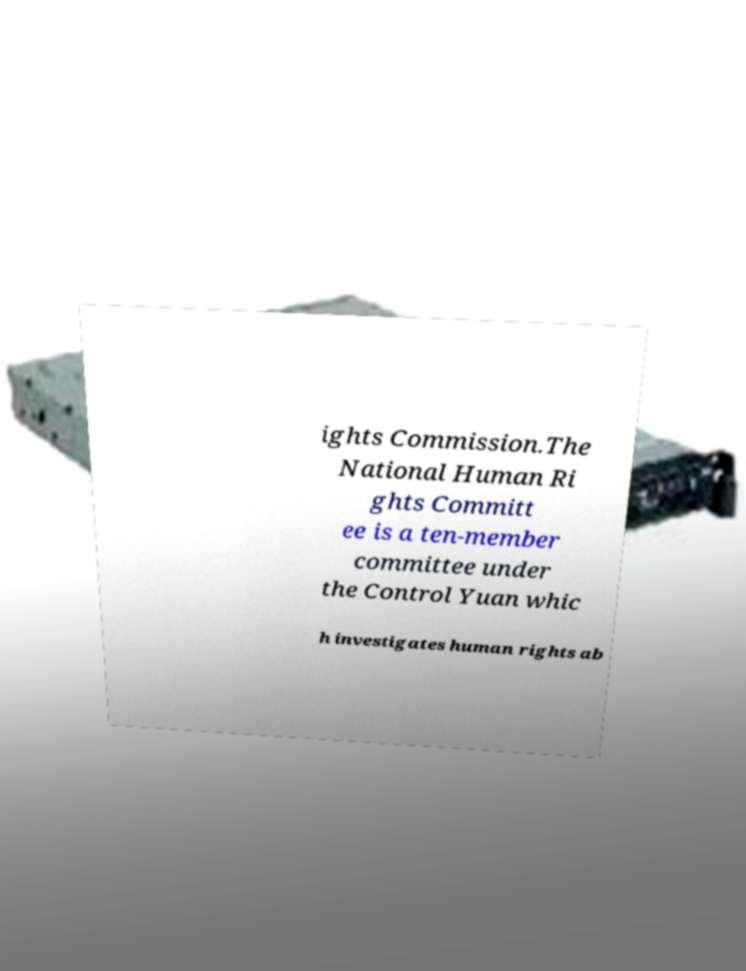Can you read and provide the text displayed in the image?This photo seems to have some interesting text. Can you extract and type it out for me? ights Commission.The National Human Ri ghts Committ ee is a ten-member committee under the Control Yuan whic h investigates human rights ab 